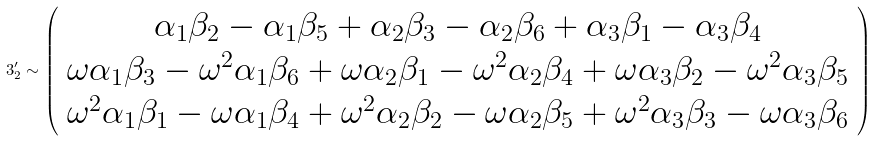<formula> <loc_0><loc_0><loc_500><loc_500>3 ^ { \prime } _ { 2 } \sim \left ( \begin{array} { c } \alpha _ { 1 } \beta _ { 2 } - \alpha _ { 1 } \beta _ { 5 } + \alpha _ { 2 } \beta _ { 3 } - \alpha _ { 2 } \beta _ { 6 } + \alpha _ { 3 } \beta _ { 1 } - \alpha _ { 3 } \beta _ { 4 } \\ \omega \alpha _ { 1 } \beta _ { 3 } - \omega ^ { 2 } \alpha _ { 1 } \beta _ { 6 } + \omega \alpha _ { 2 } \beta _ { 1 } - \omega ^ { 2 } \alpha _ { 2 } \beta _ { 4 } + \omega \alpha _ { 3 } \beta _ { 2 } - \omega ^ { 2 } \alpha _ { 3 } \beta _ { 5 } \\ \omega ^ { 2 } \alpha _ { 1 } \beta _ { 1 } - \omega \alpha _ { 1 } \beta _ { 4 } + \omega ^ { 2 } \alpha _ { 2 } \beta _ { 2 } - \omega \alpha _ { 2 } \beta _ { 5 } + \omega ^ { 2 } \alpha _ { 3 } \beta _ { 3 } - \omega \alpha _ { 3 } \beta _ { 6 } \end{array} \right )</formula> 